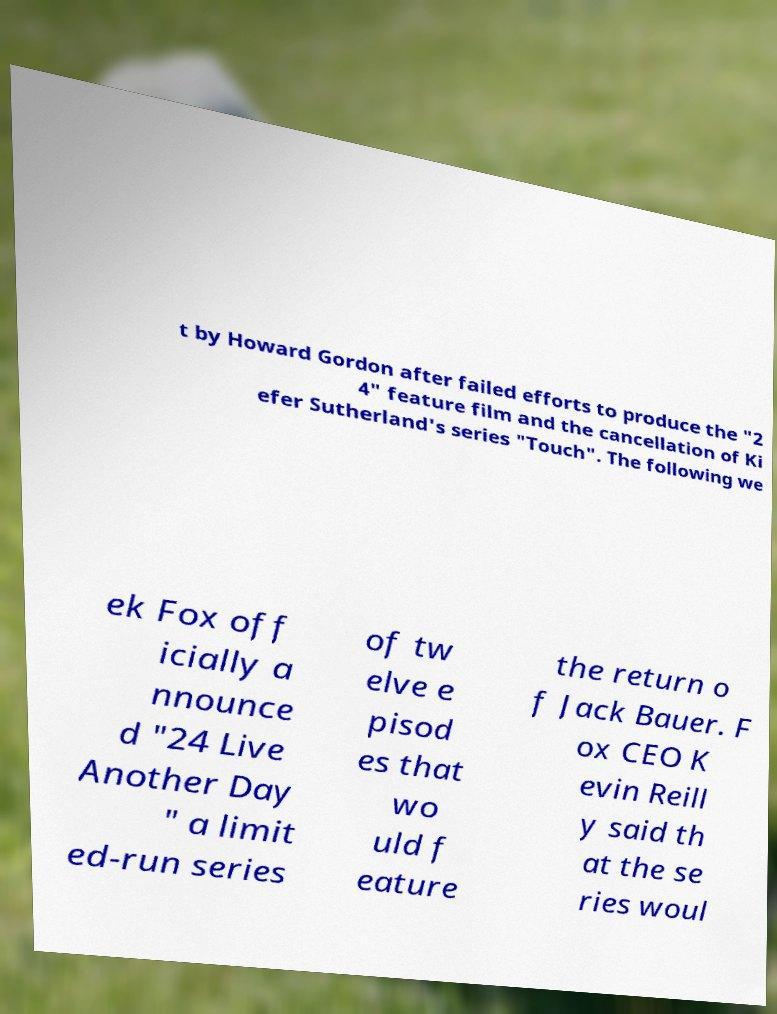Can you accurately transcribe the text from the provided image for me? t by Howard Gordon after failed efforts to produce the "2 4" feature film and the cancellation of Ki efer Sutherland's series "Touch". The following we ek Fox off icially a nnounce d "24 Live Another Day " a limit ed-run series of tw elve e pisod es that wo uld f eature the return o f Jack Bauer. F ox CEO K evin Reill y said th at the se ries woul 